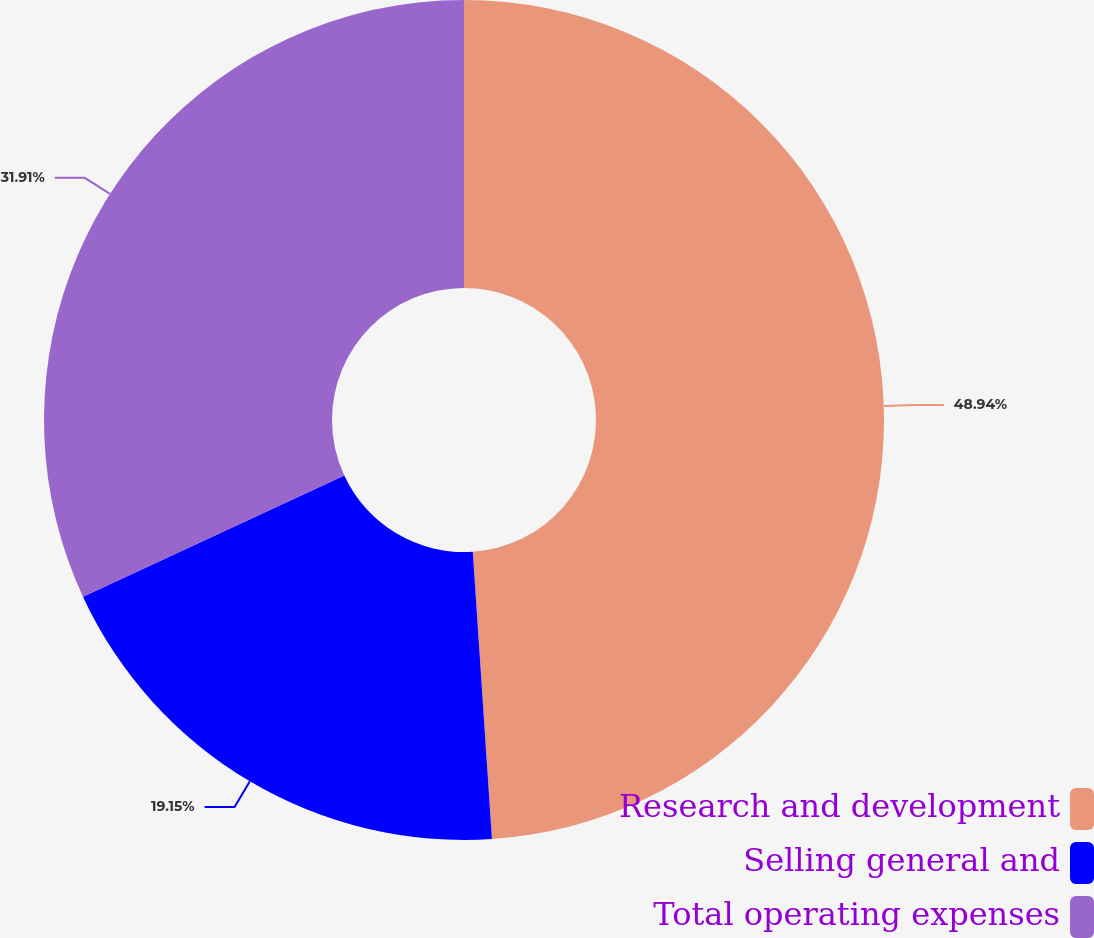<chart> <loc_0><loc_0><loc_500><loc_500><pie_chart><fcel>Research and development<fcel>Selling general and<fcel>Total operating expenses<nl><fcel>48.94%<fcel>19.15%<fcel>31.91%<nl></chart> 